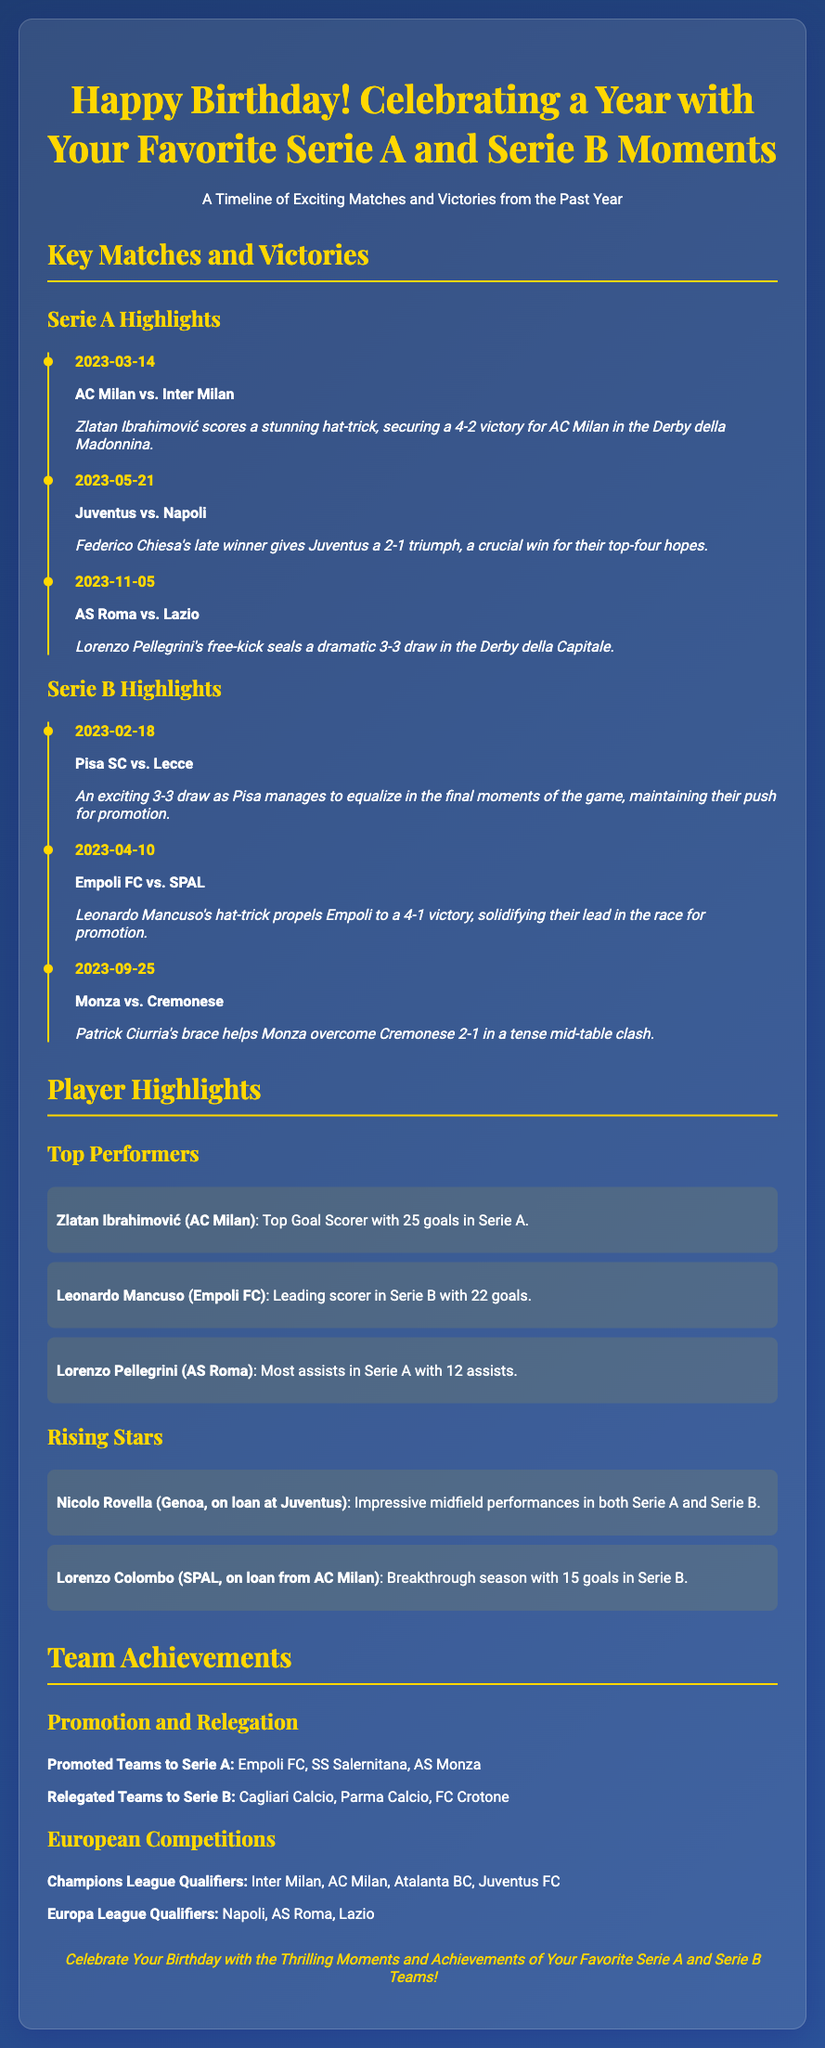What is the title of the card? The title is presented prominently at the top of the document as a celebration of the recipient's birthday and favorite football moments.
Answer: Happy Birthday! Celebrating a Year with Your Favorite Serie A and Serie B Moments Which player scores a hat-trick in the Derby della Madonnina? This information is listed in the Serie A Highlights section, detailing a key match from the past year.
Answer: Zlatan Ibrahimović What is the date of the Juventus vs. Napoli match? The date is specified in the timeline of key matches within the Serie A Highlights section.
Answer: 2023-05-21 How many goals did Leonardo Mancuso score in Serie B? This piece of information is mentioned under the Player Highlights section summarizing his achievements.
Answer: 22 goals Which teams were promoted to Serie A? This information lists the successful teams in the team achievements section concerning promotion.
Answer: Empoli FC, SS Salernitana, AS Monza What is the highlight of the match on 2023-02-18? The description captures the thrilling moment of a specific match in the Serie B Highlights.
Answer: An exciting 3-3 draw Who is the top goal scorer in Serie A? The document specifies the leading player for goals scored in Serie A under Player Highlights.
Answer: Zlatan Ibrahimović How many assists does Lorenzo Pellegrini have? The number of assists is highlighted alongside his achievements within the Player Highlights section.
Answer: 12 assists 